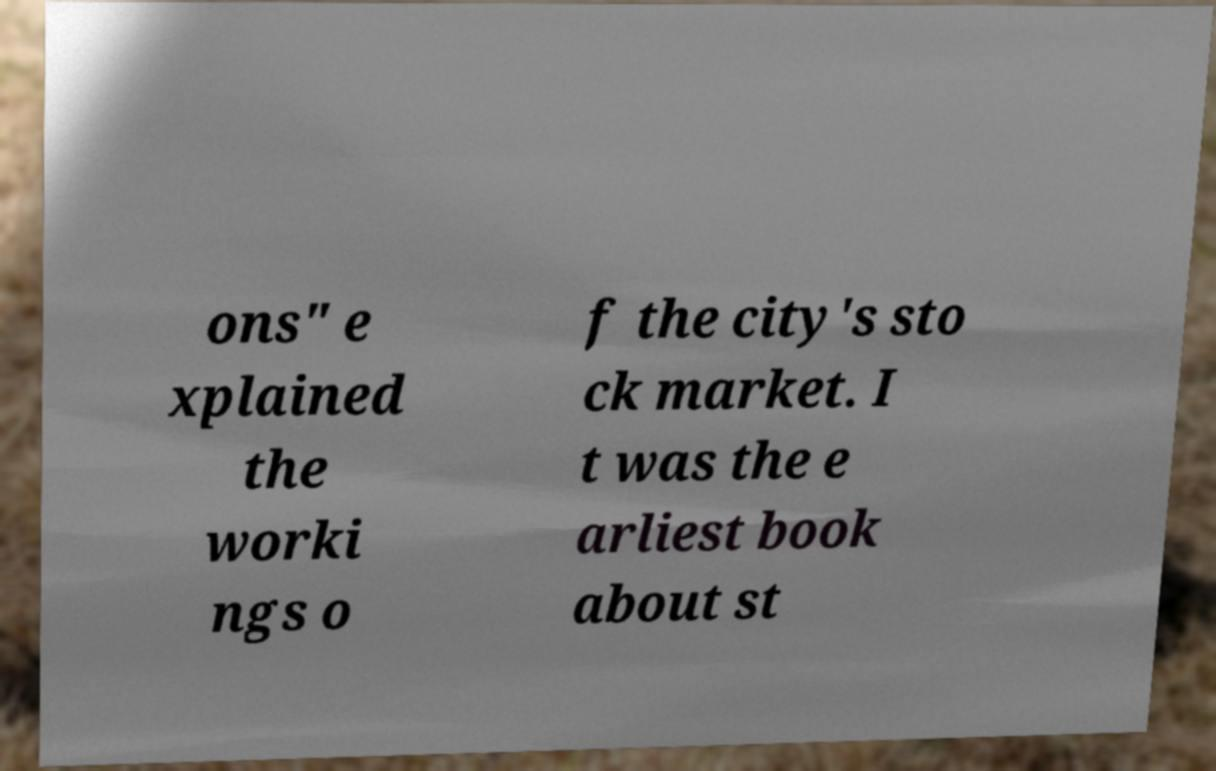Please read and relay the text visible in this image. What does it say? ons" e xplained the worki ngs o f the city's sto ck market. I t was the e arliest book about st 